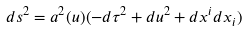Convert formula to latex. <formula><loc_0><loc_0><loc_500><loc_500>d s ^ { 2 } = a ^ { 2 } ( u ) ( - d \tau ^ { 2 } + d u ^ { 2 } + d x ^ { i } d x _ { i } )</formula> 